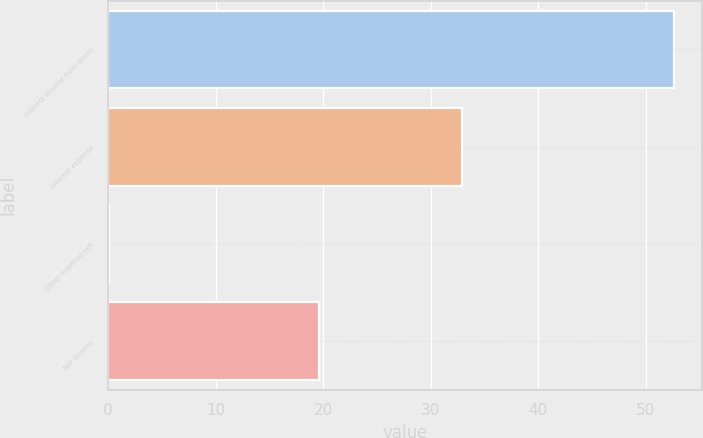<chart> <loc_0><loc_0><loc_500><loc_500><bar_chart><fcel>Interest income from direct<fcel>Interest expense<fcel>Other expense net<fcel>Net Income<nl><fcel>52.6<fcel>32.9<fcel>0.1<fcel>19.6<nl></chart> 